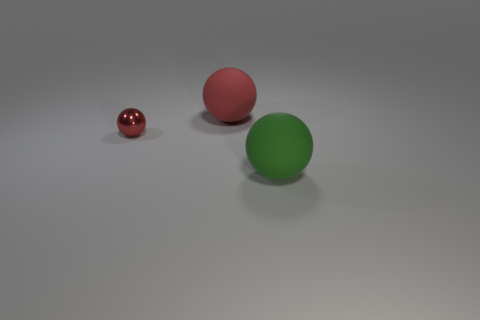What is the size of the red rubber thing that is the same shape as the red metallic object?
Make the answer very short. Large. What number of other things have the same color as the tiny metal thing?
Your answer should be compact. 1. There is a large rubber object that is in front of the rubber thing behind the small red thing on the left side of the big red matte object; what is its color?
Ensure brevity in your answer.  Green. There is a green ball; are there any shiny things in front of it?
Your answer should be compact. No. What is the size of the other sphere that is the same color as the tiny metallic sphere?
Your response must be concise. Large. Is there a tiny red object that has the same material as the green ball?
Give a very brief answer. No. The small thing is what color?
Provide a succinct answer. Red. Do the large object that is behind the green ball and the large green rubber object have the same shape?
Ensure brevity in your answer.  Yes. There is a big thing in front of the red shiny thing left of the large object in front of the tiny sphere; what shape is it?
Provide a short and direct response. Sphere. What is the big thing that is behind the small metallic ball made of?
Provide a succinct answer. Rubber. 